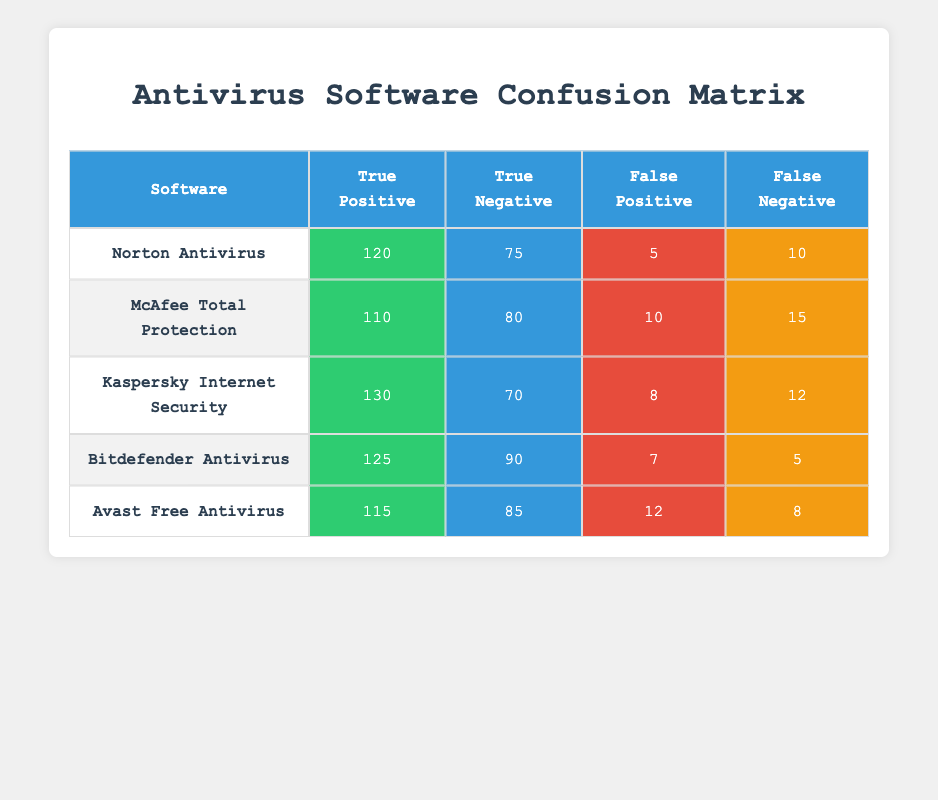What is the true positive rate for Norton Antivirus? The true positive rate is calculated by dividing the true positives by the sum of true positives and false negatives. For Norton, this is 120 / (120 + 10) = 120 / 130, which equals approximately 0.923 or 92.3%.
Answer: 92.3% Which antivirus has the highest true negative count? By examining the table, Kaspersky Internet Security has a true negative count of 70, which is less than the true negative counts of the other antivirus software. The highest count of true negatives is for Bitdefender Antivirus, which is 90.
Answer: Bitdefender Antivirus What is the total number of false positives across all antivirus software? The total false positives can be calculated by summing the false positive counts: 5 + 10 + 8 + 7 + 12 = 42.
Answer: 42 Does McAfee Total Protection have a higher false negative count than Norton Antivirus? McAfee's false negative count is 15 while Norton's count is 10. Comparing these, McAfee has a higher count of false negatives.
Answer: Yes What is the average true positive across all antivirus software? To find the average, sum all true positives: 120 + 110 + 130 + 125 + 115 = 600. Then divide by the number of software (5): 600 / 5 = 120.
Answer: 120 Which antivirus software has the lowest accuracy in terms of true positive and true negative combined? The accuracy can be calculated by adding true positives and true negatives. Norton: 120 + 75 = 195, McAfee: 110 + 80 = 190, Kaspersky: 130 + 70 = 200, Bitdefender: 125 + 90 = 215, Avast: 115 + 85 = 200. McAfee Total Protection has the lowest combined accuracy at 190.
Answer: McAfee Total Protection Is it true that all antivirus programs have true positive counts exceeding 100? Reviewing the true positive counts, Norton has 120, McAfee has 110, Kaspersky has 130, Bitdefender has 125, and Avast has 115. All are greater than 100.
Answer: Yes What is the difference in the false positive count between Norton Antivirus and Avast Free Antivirus? For Norton, the false positive count is 5, and for Avast, it is 12. The difference is 12 - 5 = 7.
Answer: 7 